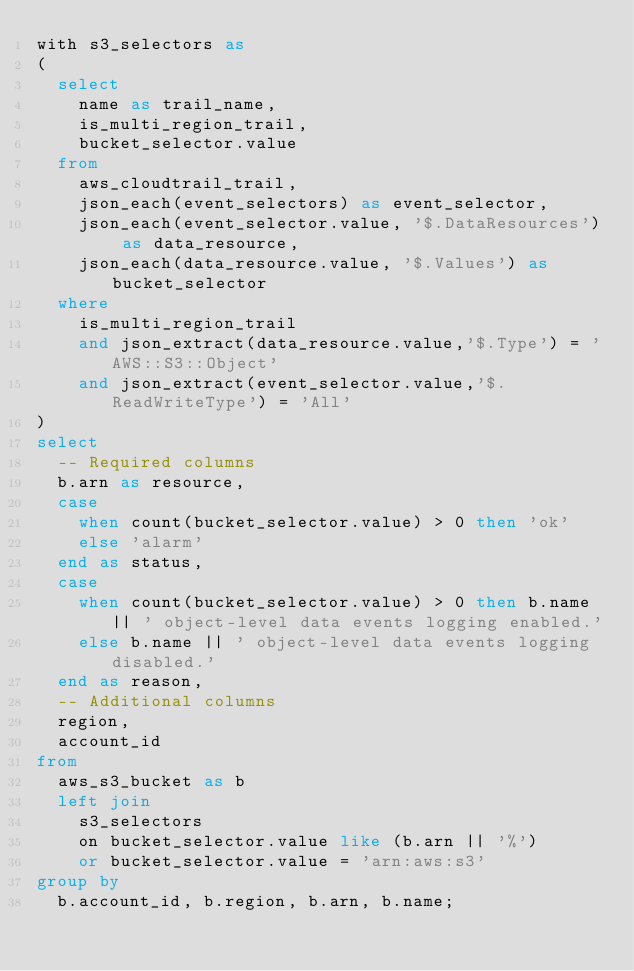Convert code to text. <code><loc_0><loc_0><loc_500><loc_500><_SQL_>with s3_selectors as
(
  select
    name as trail_name,
    is_multi_region_trail,
    bucket_selector.value
  from
    aws_cloudtrail_trail,
    json_each(event_selectors) as event_selector,
    json_each(event_selector.value, '$.DataResources') as data_resource,
    json_each(data_resource.value, '$.Values') as bucket_selector
  where
    is_multi_region_trail
    and json_extract(data_resource.value,'$.Type') = 'AWS::S3::Object'
    and json_extract(event_selector.value,'$.ReadWriteType') = 'All'
)
select
  -- Required columns
  b.arn as resource,
  case
    when count(bucket_selector.value) > 0 then 'ok'
    else 'alarm'
  end as status,
  case
    when count(bucket_selector.value) > 0 then b.name || ' object-level data events logging enabled.'
    else b.name || ' object-level data events logging disabled.'
  end as reason,
  -- Additional columns
  region,
  account_id
from
  aws_s3_bucket as b
  left join
    s3_selectors
    on bucket_selector.value like (b.arn || '%')
    or bucket_selector.value = 'arn:aws:s3'
group by
  b.account_id, b.region, b.arn, b.name;</code> 